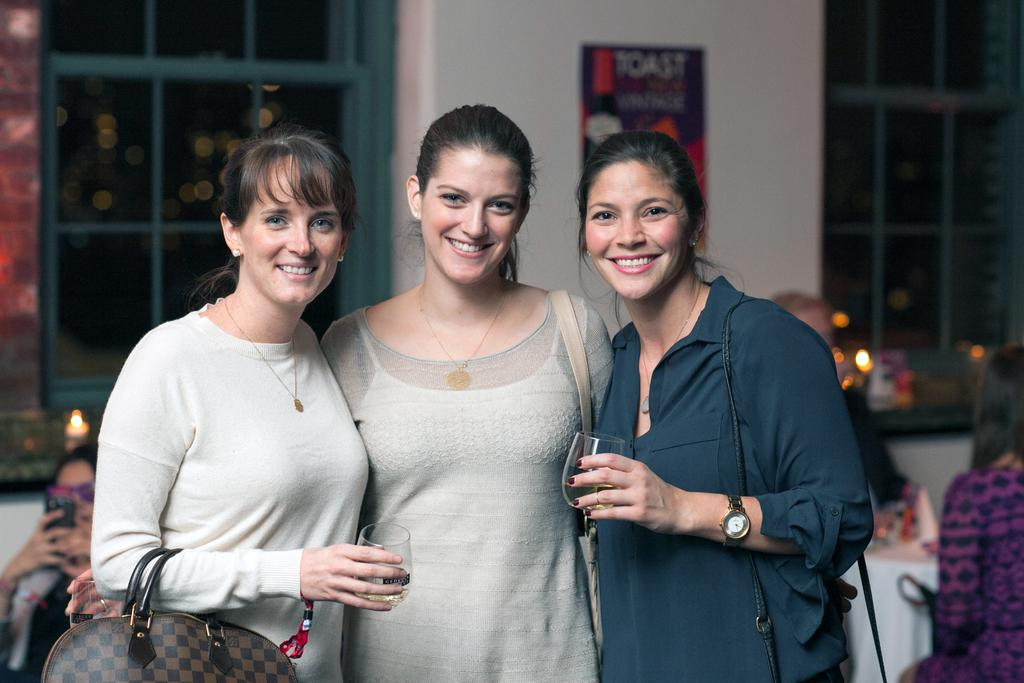What are the two women in the image holding? The two women are standing and holding a glass in their hands. Can you describe the position of the third woman in the image? There is another woman standing between the two women holding glasses. Are there any other people visible in the image? Yes, there are other people visible behind the three women. What type of jelly can be seen on the floor in the image? There is no jelly present on the floor in the image. Can you describe the veins in the woman's hands in the image? The image does not provide enough detail to describe the veins in the women's hands. 